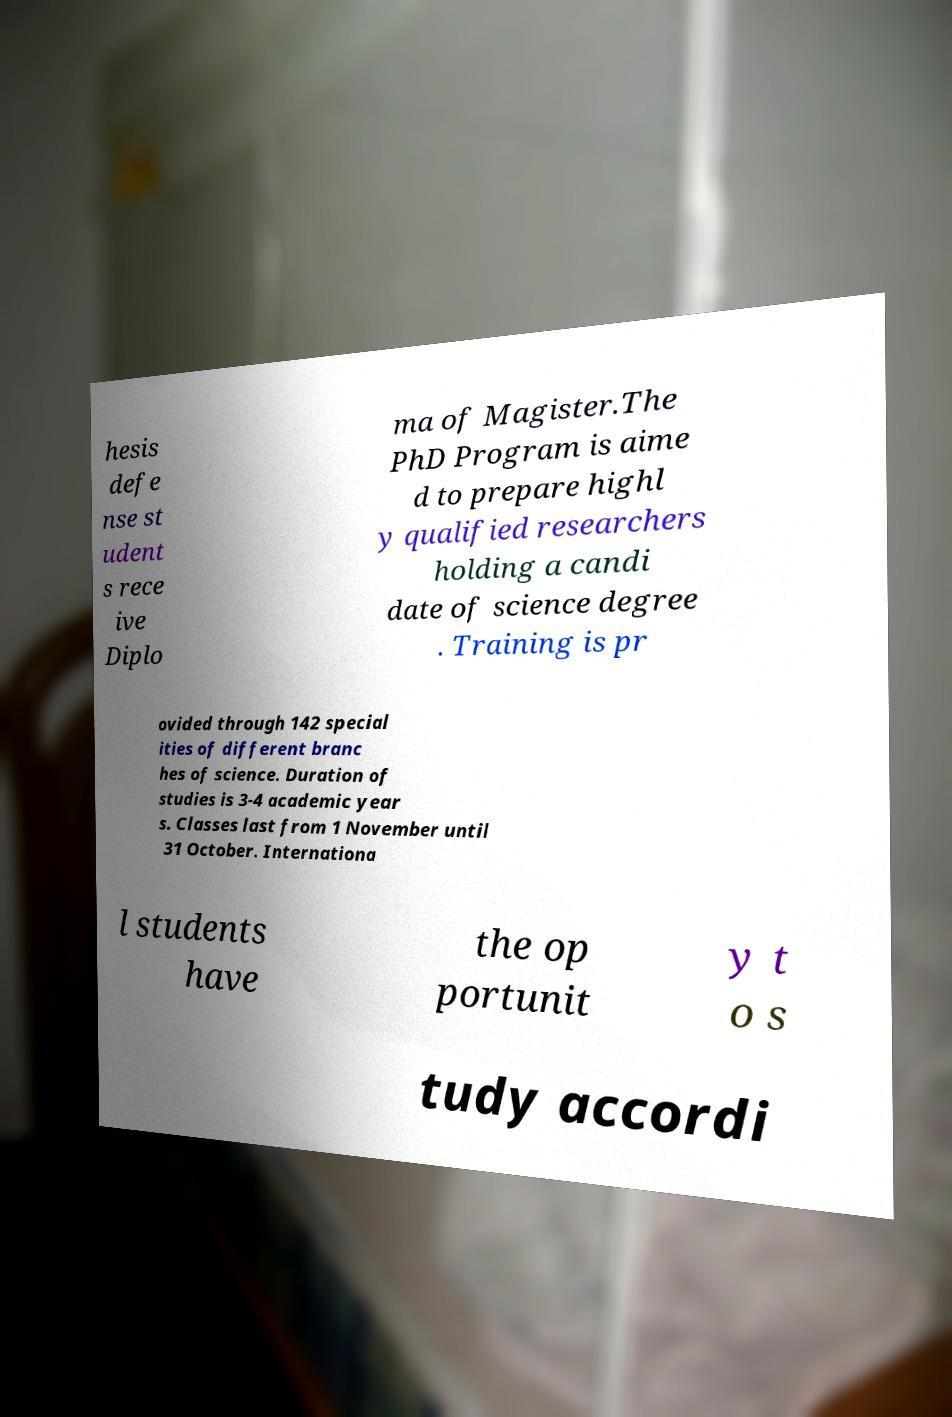Can you read and provide the text displayed in the image?This photo seems to have some interesting text. Can you extract and type it out for me? hesis defe nse st udent s rece ive Diplo ma of Magister.The PhD Program is aime d to prepare highl y qualified researchers holding a candi date of science degree . Training is pr ovided through 142 special ities of different branc hes of science. Duration of studies is 3-4 academic year s. Classes last from 1 November until 31 October. Internationa l students have the op portunit y t o s tudy accordi 